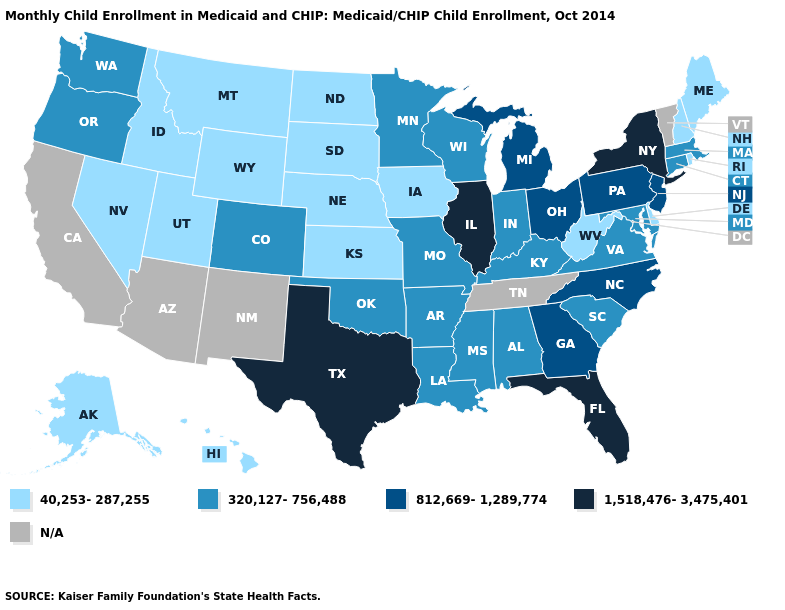Does Oregon have the lowest value in the West?
Answer briefly. No. Name the states that have a value in the range 1,518,476-3,475,401?
Keep it brief. Florida, Illinois, New York, Texas. Among the states that border Arkansas , does Mississippi have the lowest value?
Keep it brief. Yes. Among the states that border Georgia , does Alabama have the highest value?
Give a very brief answer. No. What is the value of Massachusetts?
Give a very brief answer. 320,127-756,488. Which states have the lowest value in the South?
Short answer required. Delaware, West Virginia. Which states hav the highest value in the Northeast?
Be succinct. New York. Among the states that border Utah , which have the highest value?
Quick response, please. Colorado. Name the states that have a value in the range 812,669-1,289,774?
Write a very short answer. Georgia, Michigan, New Jersey, North Carolina, Ohio, Pennsylvania. Name the states that have a value in the range N/A?
Quick response, please. Arizona, California, New Mexico, Tennessee, Vermont. Which states have the lowest value in the Northeast?
Keep it brief. Maine, New Hampshire, Rhode Island. Name the states that have a value in the range 40,253-287,255?
Write a very short answer. Alaska, Delaware, Hawaii, Idaho, Iowa, Kansas, Maine, Montana, Nebraska, Nevada, New Hampshire, North Dakota, Rhode Island, South Dakota, Utah, West Virginia, Wyoming. Name the states that have a value in the range N/A?
Keep it brief. Arizona, California, New Mexico, Tennessee, Vermont. Among the states that border Iowa , does Minnesota have the lowest value?
Answer briefly. No. 